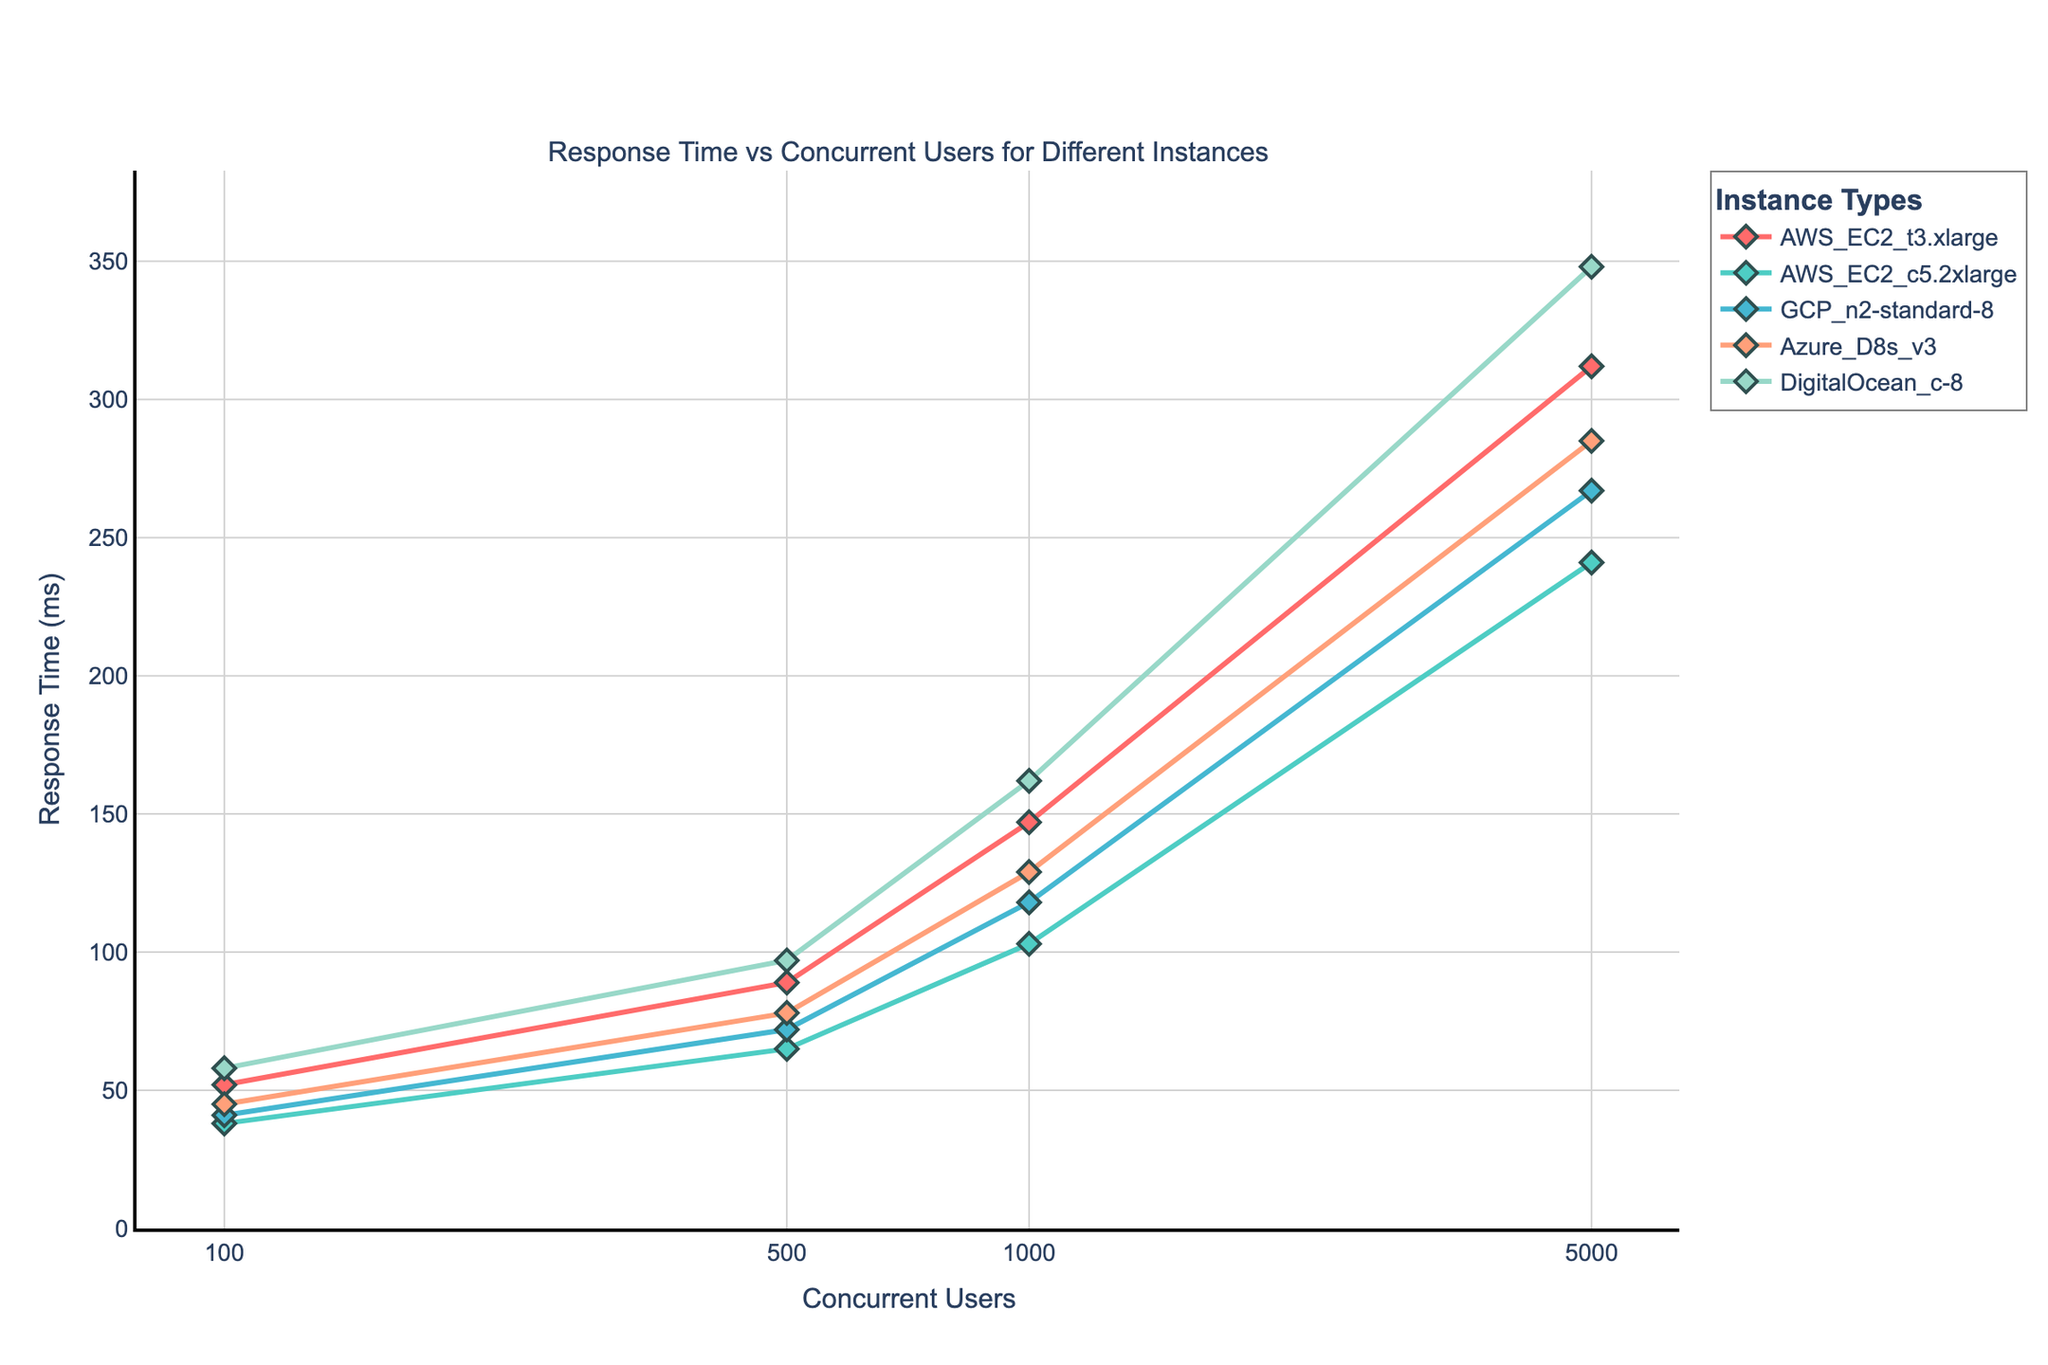What is the x-axis label in the plot? The x-axis label represents the number of concurrent users being tested for each server instance. It is indicated in the plot as 'Concurrent Users'.
Answer: Concurrent Users What is the response time for AWS EC2 t3.xlarge at 1000 concurrent users? To find the response time for AWS EC2 t3.xlarge at 1000 concurrent users, locate the point on the plot corresponding to AWS EC2 t3.xlarge on the x-axis at 1000 concurrent users and read the y-axis value. The response time is 147 ms.
Answer: 147 ms Which instance has the lowest response time at 500 concurrent users? To find the instance with the lowest response time at 500 concurrent users, check the response times on the plot for each instance at the point where the x-axis is 500 concurrent users. AWS EC2 c5.2xlarge has the lowest response time of 65 ms.
Answer: AWS EC2 c5.2xlarge Between which two instances is the difference in response times the greatest at 5000 concurrent users? To determine this, look at the response times for all instances at 5000 concurrent users. The instances with the highest and lowest response times are DigitalOcean c-8 (348 ms) and AWS EC2 c5.2xlarge (241 ms). The difference is 348 - 241 = 107 ms.
Answer: DigitalOcean c-8 and AWS EC2 c5.2xlarge Rank the server instances from lowest to highest response time at 100 concurrent users. To rank the instances, compare the response times at 100 concurrent users for each instance: AWS EC2 c5.2xlarge (38 ms), GCP n2-standard-8 (41 ms), Azure D8s v3 (45 ms), AWS EC2 t3.xlarge (52 ms), DigitalOcean c-8 (58 ms).
Answer: AWS EC2 c5.2xlarge < GCP n2-standard-8 < Azure D8s v3 < AWS EC2 t3.xlarge < DigitalOcean c-8 What trend do you observe for the response times of the instances as the number of concurrent users increases? Observing the response times as the number of concurrent users increases, all instances show an upward trend, indicating that response times increase proportionally with more concurrent users.
Answer: Increase If AWS EC2 t3.xlarge continues the same trend, estimate the response time at 7000 concurrent users. Based on the trend from 100 to 5000 concurrent users, AWS EC2 t3.xlarge's response time increases non-linearly. Linear interpolation between the last two known points (312 ms at 5000 users and 147 ms at 1000 users) suggests a steeper curve, estimating around 369 ms.
Answer: 369 ms 